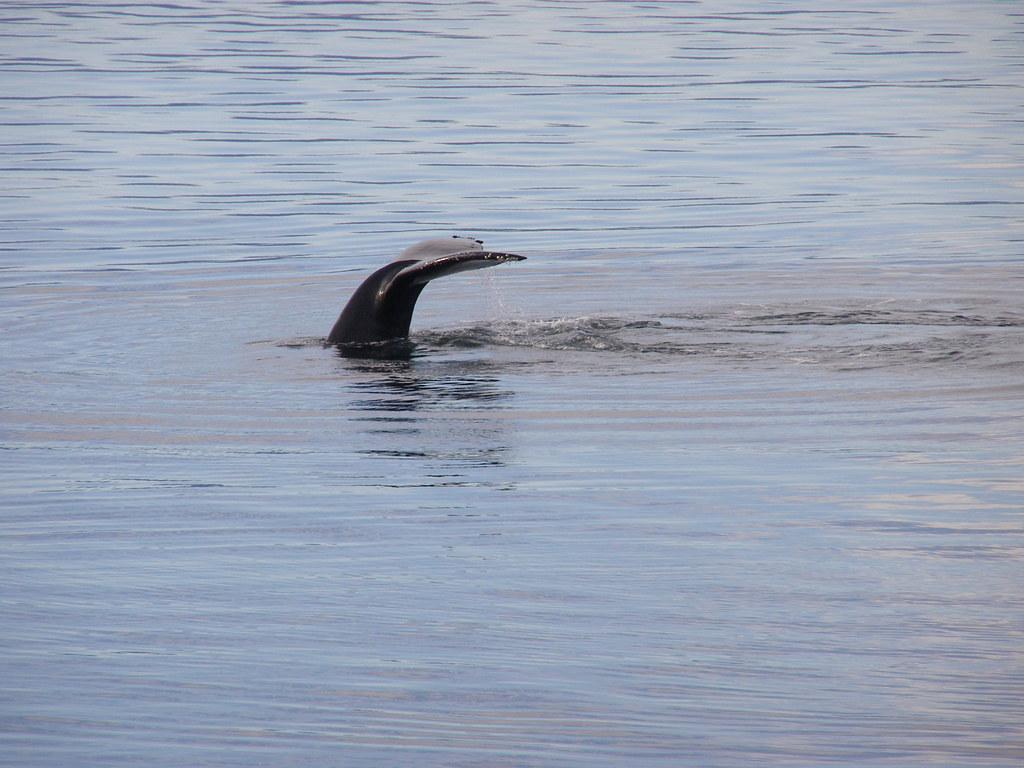What type of animal can be seen in the image? There is an aquatic animal in the image. What color is the water surrounding the animal? The water in the image is blue. How many chairs are visible in the image? There are no chairs present in the image. What is the tendency of the aquatic animal to cover itself in the image? There is no indication of the aquatic animal's tendency to cover itself in the image. 